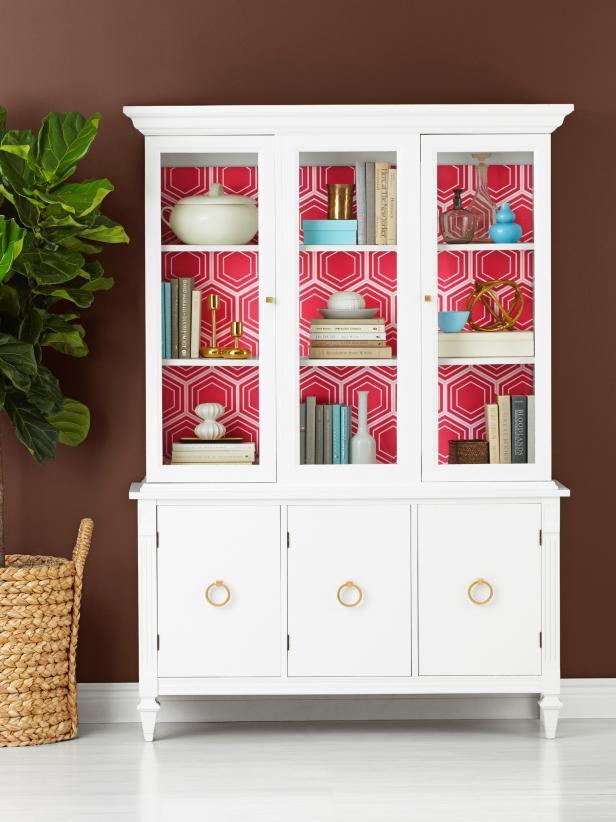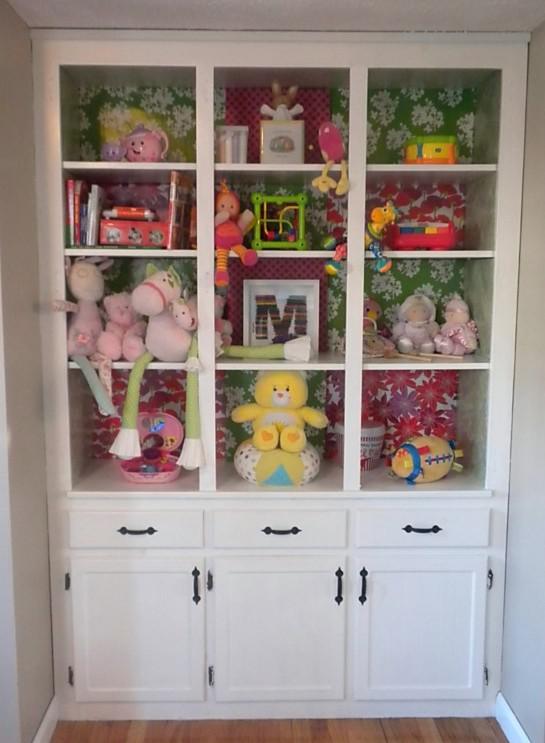The first image is the image on the left, the second image is the image on the right. For the images shown, is this caption "An image shows a white cabinet with feet and a scroll-curved bottom." true? Answer yes or no. No. 